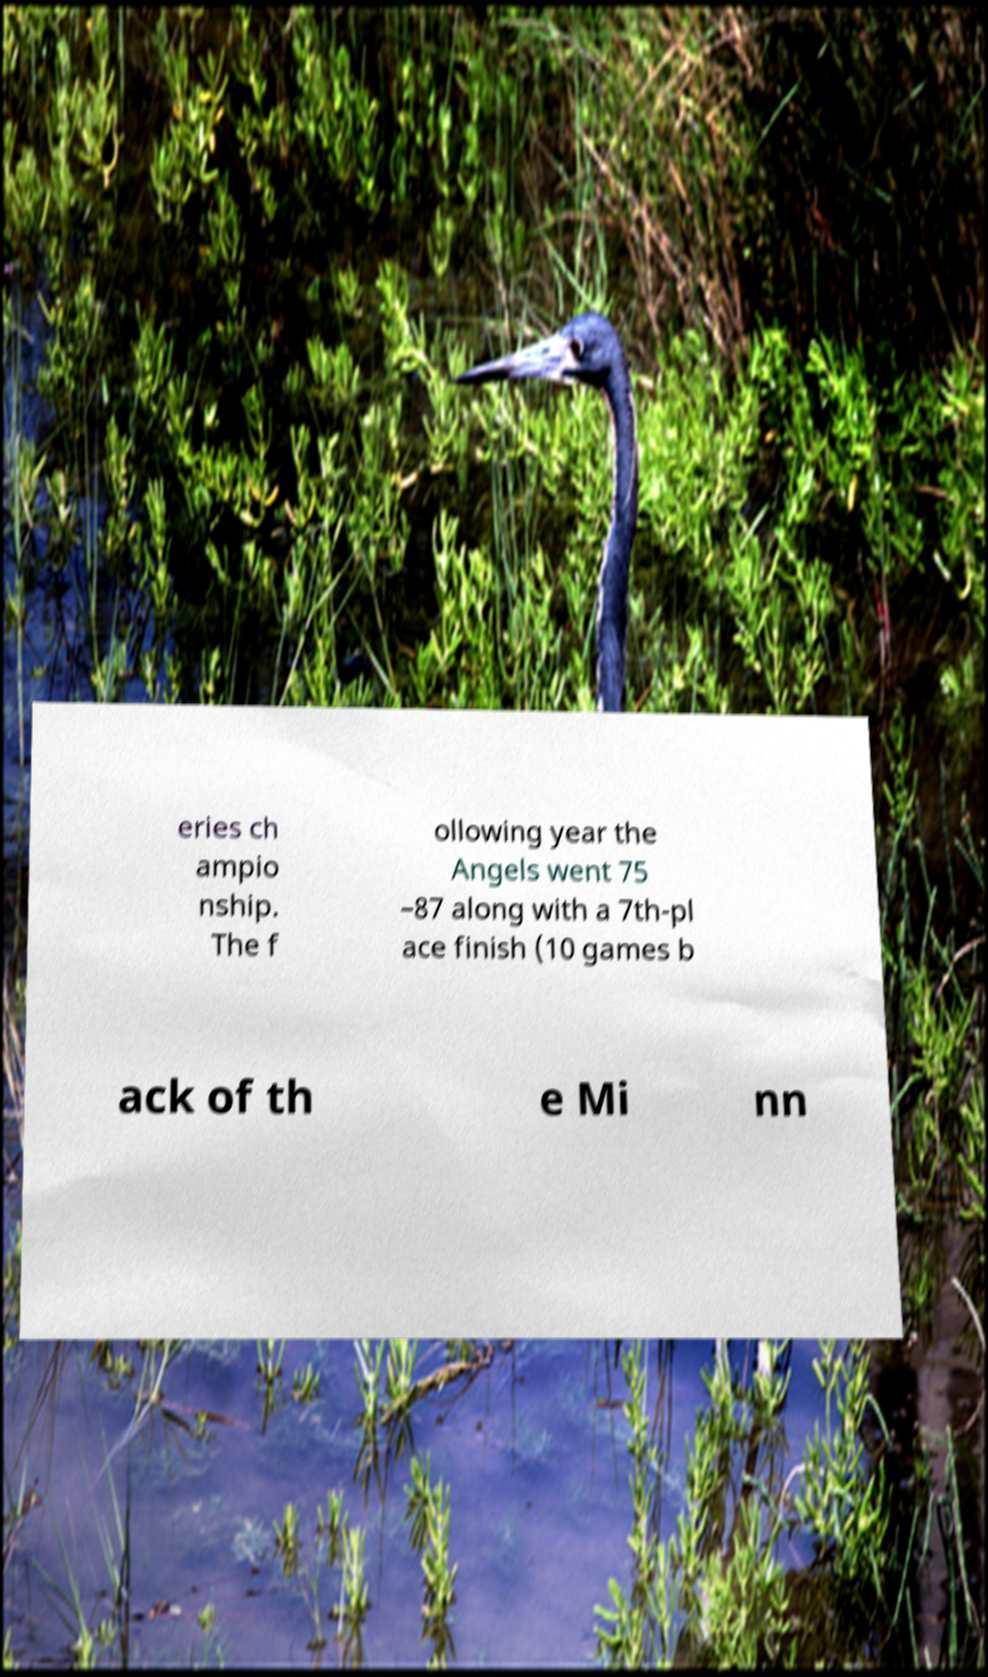There's text embedded in this image that I need extracted. Can you transcribe it verbatim? eries ch ampio nship. The f ollowing year the Angels went 75 –87 along with a 7th-pl ace finish (10 games b ack of th e Mi nn 